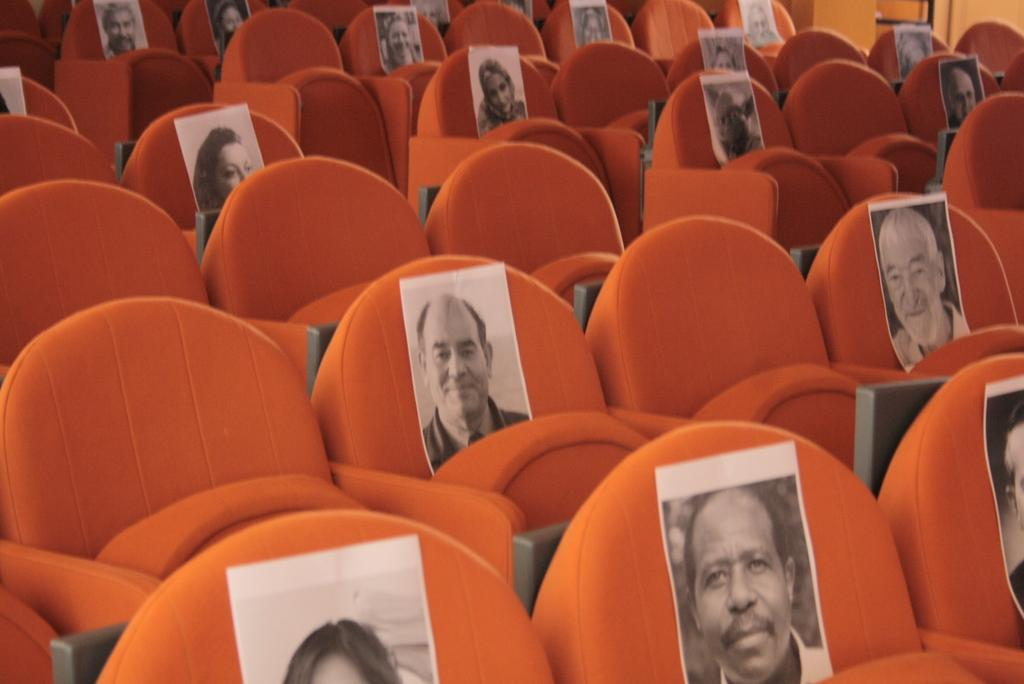What is the primary feature of the seats in the image? Each seat has a photo printed on it. How many seats can be seen in the image? There are many seats in the image. What type of sponge is being used to clean the disgusting lip marks on the seats? There is no mention of sponge, disgust, or lip marks in the image, so it is not possible to answer this question. 